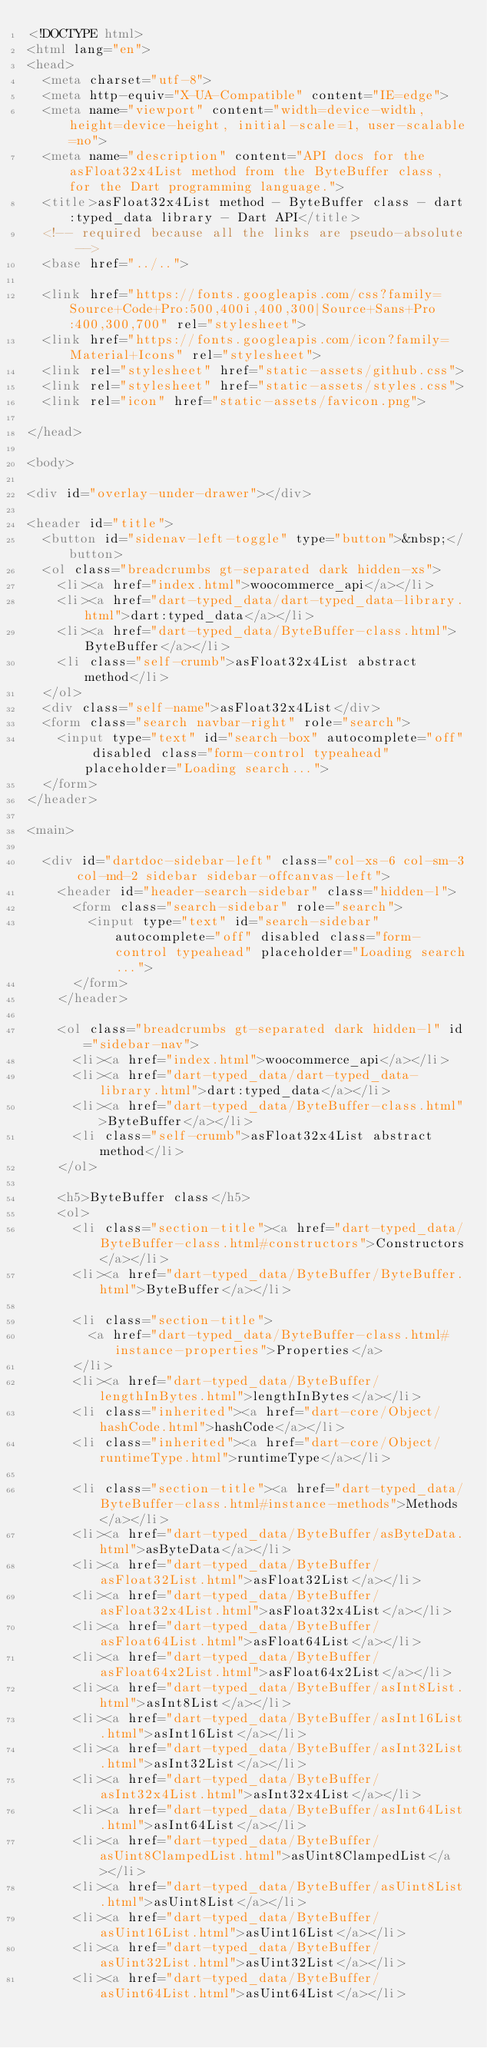Convert code to text. <code><loc_0><loc_0><loc_500><loc_500><_HTML_><!DOCTYPE html>
<html lang="en">
<head>
  <meta charset="utf-8">
  <meta http-equiv="X-UA-Compatible" content="IE=edge">
  <meta name="viewport" content="width=device-width, height=device-height, initial-scale=1, user-scalable=no">
  <meta name="description" content="API docs for the asFloat32x4List method from the ByteBuffer class, for the Dart programming language.">
  <title>asFloat32x4List method - ByteBuffer class - dart:typed_data library - Dart API</title>
  <!-- required because all the links are pseudo-absolute -->
  <base href="../..">

  <link href="https://fonts.googleapis.com/css?family=Source+Code+Pro:500,400i,400,300|Source+Sans+Pro:400,300,700" rel="stylesheet">
  <link href="https://fonts.googleapis.com/icon?family=Material+Icons" rel="stylesheet">
  <link rel="stylesheet" href="static-assets/github.css">
  <link rel="stylesheet" href="static-assets/styles.css">
  <link rel="icon" href="static-assets/favicon.png">
  
</head>

<body>

<div id="overlay-under-drawer"></div>

<header id="title">
  <button id="sidenav-left-toggle" type="button">&nbsp;</button>
  <ol class="breadcrumbs gt-separated dark hidden-xs">
    <li><a href="index.html">woocommerce_api</a></li>
    <li><a href="dart-typed_data/dart-typed_data-library.html">dart:typed_data</a></li>
    <li><a href="dart-typed_data/ByteBuffer-class.html">ByteBuffer</a></li>
    <li class="self-crumb">asFloat32x4List abstract method</li>
  </ol>
  <div class="self-name">asFloat32x4List</div>
  <form class="search navbar-right" role="search">
    <input type="text" id="search-box" autocomplete="off" disabled class="form-control typeahead" placeholder="Loading search...">
  </form>
</header>

<main>

  <div id="dartdoc-sidebar-left" class="col-xs-6 col-sm-3 col-md-2 sidebar sidebar-offcanvas-left">
    <header id="header-search-sidebar" class="hidden-l">
      <form class="search-sidebar" role="search">
        <input type="text" id="search-sidebar" autocomplete="off" disabled class="form-control typeahead" placeholder="Loading search...">
      </form>
    </header>
    
    <ol class="breadcrumbs gt-separated dark hidden-l" id="sidebar-nav">
      <li><a href="index.html">woocommerce_api</a></li>
      <li><a href="dart-typed_data/dart-typed_data-library.html">dart:typed_data</a></li>
      <li><a href="dart-typed_data/ByteBuffer-class.html">ByteBuffer</a></li>
      <li class="self-crumb">asFloat32x4List abstract method</li>
    </ol>
    
    <h5>ByteBuffer class</h5>
    <ol>
      <li class="section-title"><a href="dart-typed_data/ByteBuffer-class.html#constructors">Constructors</a></li>
      <li><a href="dart-typed_data/ByteBuffer/ByteBuffer.html">ByteBuffer</a></li>
    
      <li class="section-title">
        <a href="dart-typed_data/ByteBuffer-class.html#instance-properties">Properties</a>
      </li>
      <li><a href="dart-typed_data/ByteBuffer/lengthInBytes.html">lengthInBytes</a></li>
      <li class="inherited"><a href="dart-core/Object/hashCode.html">hashCode</a></li>
      <li class="inherited"><a href="dart-core/Object/runtimeType.html">runtimeType</a></li>
    
      <li class="section-title"><a href="dart-typed_data/ByteBuffer-class.html#instance-methods">Methods</a></li>
      <li><a href="dart-typed_data/ByteBuffer/asByteData.html">asByteData</a></li>
      <li><a href="dart-typed_data/ByteBuffer/asFloat32List.html">asFloat32List</a></li>
      <li><a href="dart-typed_data/ByteBuffer/asFloat32x4List.html">asFloat32x4List</a></li>
      <li><a href="dart-typed_data/ByteBuffer/asFloat64List.html">asFloat64List</a></li>
      <li><a href="dart-typed_data/ByteBuffer/asFloat64x2List.html">asFloat64x2List</a></li>
      <li><a href="dart-typed_data/ByteBuffer/asInt8List.html">asInt8List</a></li>
      <li><a href="dart-typed_data/ByteBuffer/asInt16List.html">asInt16List</a></li>
      <li><a href="dart-typed_data/ByteBuffer/asInt32List.html">asInt32List</a></li>
      <li><a href="dart-typed_data/ByteBuffer/asInt32x4List.html">asInt32x4List</a></li>
      <li><a href="dart-typed_data/ByteBuffer/asInt64List.html">asInt64List</a></li>
      <li><a href="dart-typed_data/ByteBuffer/asUint8ClampedList.html">asUint8ClampedList</a></li>
      <li><a href="dart-typed_data/ByteBuffer/asUint8List.html">asUint8List</a></li>
      <li><a href="dart-typed_data/ByteBuffer/asUint16List.html">asUint16List</a></li>
      <li><a href="dart-typed_data/ByteBuffer/asUint32List.html">asUint32List</a></li>
      <li><a href="dart-typed_data/ByteBuffer/asUint64List.html">asUint64List</a></li></code> 